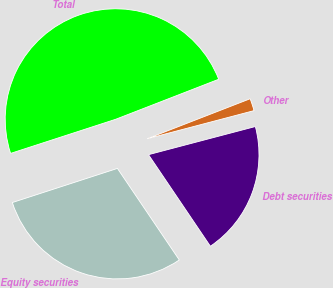Convert chart. <chart><loc_0><loc_0><loc_500><loc_500><pie_chart><fcel>Equity securities<fcel>Debt securities<fcel>Other<fcel>Total<nl><fcel>29.46%<fcel>19.64%<fcel>1.8%<fcel>49.1%<nl></chart> 